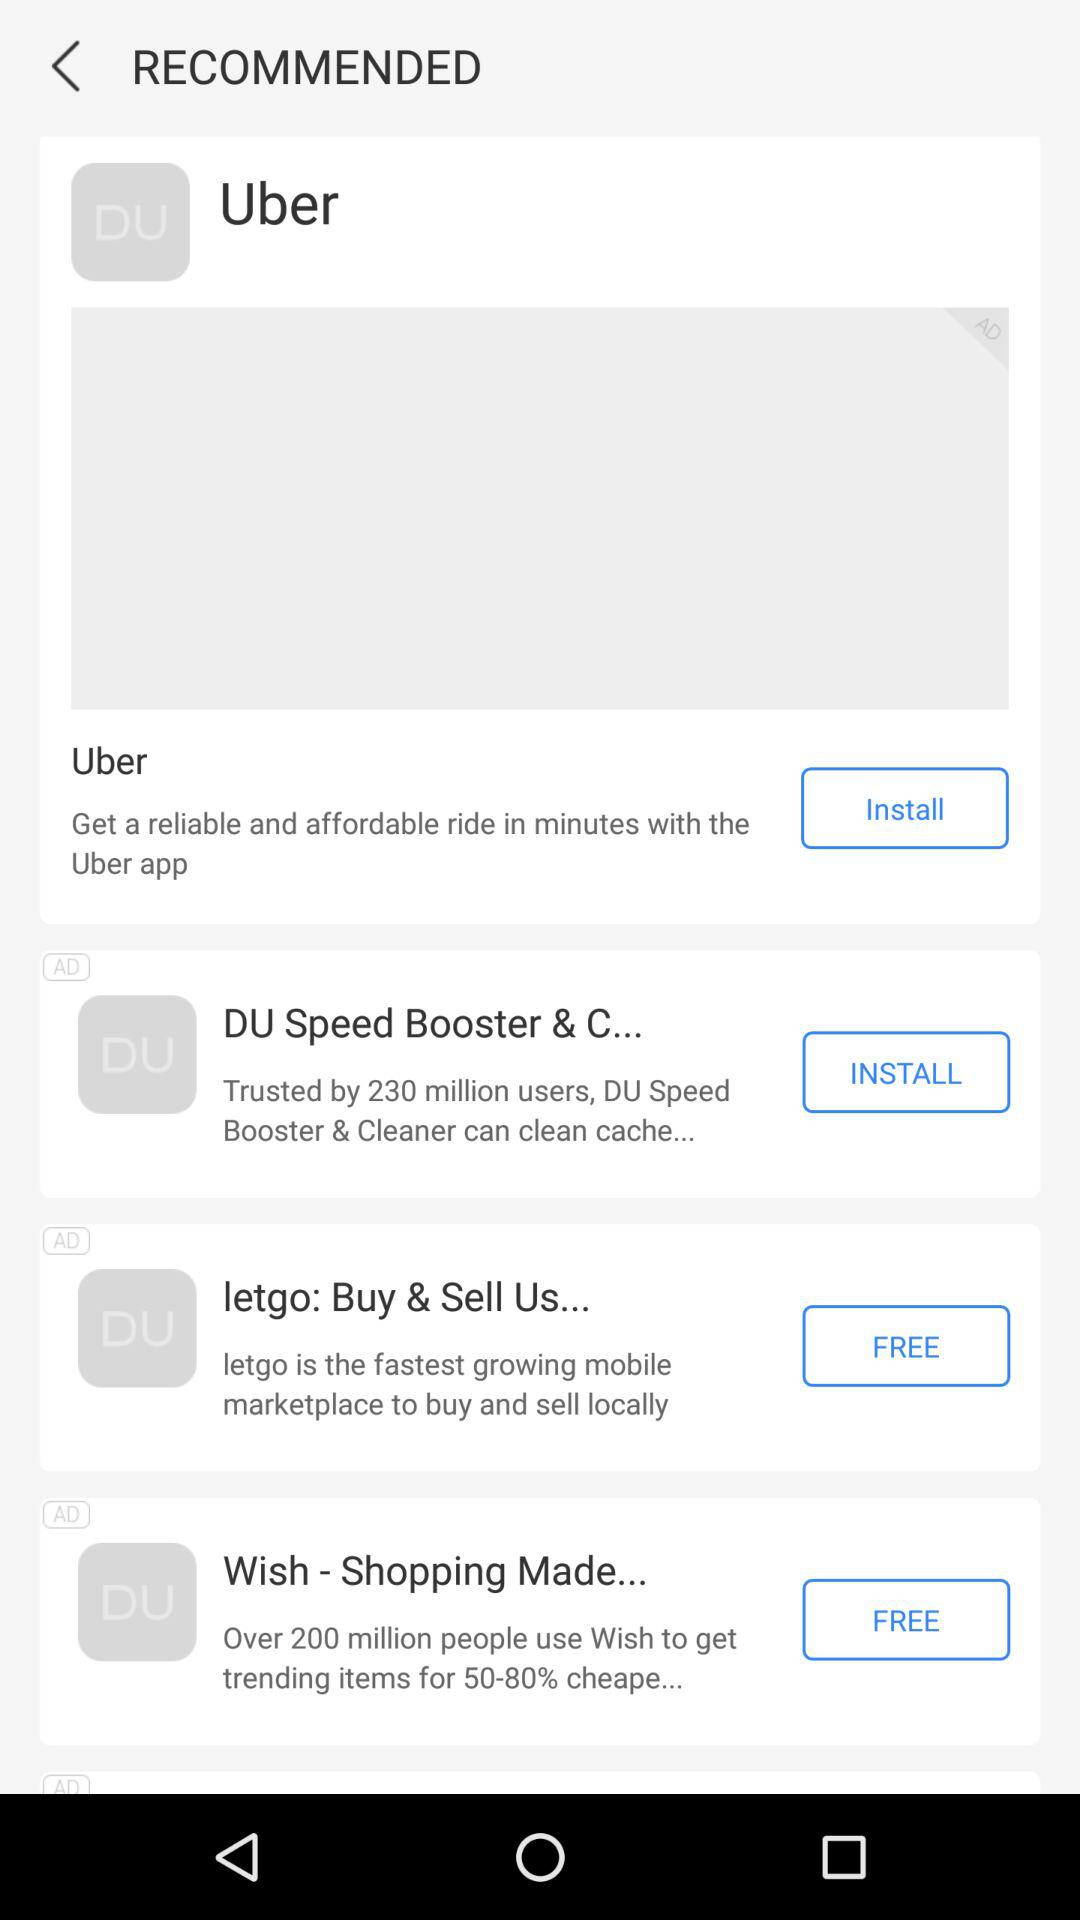How many people trust the DU speed booster application? There are 230 million people who trusted the DU speed booster application. 